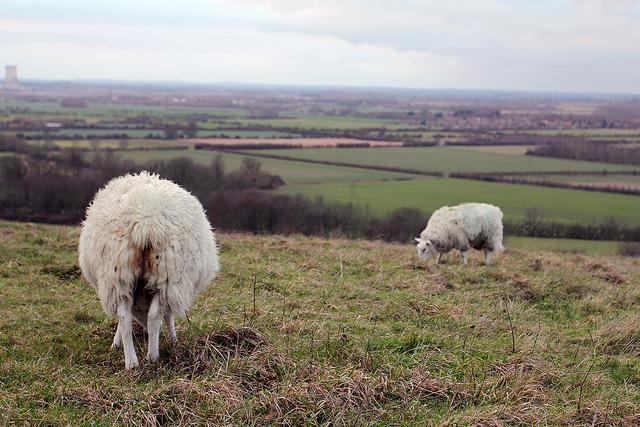How many sheep are there?
Give a very brief answer. 2. How many animals are in the picture?
Give a very brief answer. 2. How many animals do you see?
Give a very brief answer. 2. How many sheep are on the grass?
Give a very brief answer. 2. How many sheep are in the photo?
Give a very brief answer. 2. 